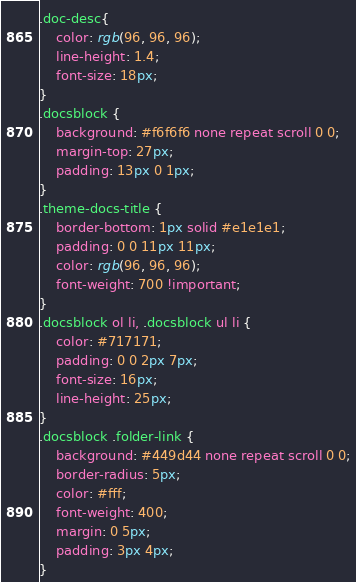<code> <loc_0><loc_0><loc_500><loc_500><_CSS_>.doc-desc{
	color: rgb(96, 96, 96); 
	line-height: 1.4; 
	font-size: 18px;
}
.docsblock {
    background: #f6f6f6 none repeat scroll 0 0;
    margin-top: 27px;
    padding: 13px 0 1px;
}
.theme-docs-title {
    border-bottom: 1px solid #e1e1e1;
    padding: 0 0 11px 11px;
    color: rgb(96, 96, 96);
    font-weight: 700 !important;
}
.docsblock ol li, .docsblock ul li {
    color: #717171;
    padding: 0 0 2px 7px;
    font-size: 16px;
    line-height: 25px;
}
.docsblock .folder-link {
    background: #449d44 none repeat scroll 0 0;
    border-radius: 5px;
    color: #fff;
    font-weight: 400;
    margin: 0 5px;
    padding: 3px 4px;
}</code> 